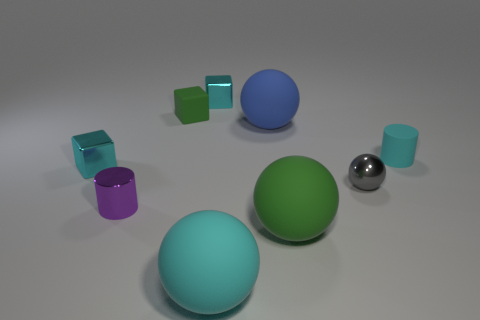Add 1 small gray metal balls. How many objects exist? 10 Subtract all cyan cubes. How many cubes are left? 1 Subtract all green cubes. How many cubes are left? 2 Subtract 2 balls. How many balls are left? 2 Add 7 tiny gray rubber spheres. How many tiny gray rubber spheres exist? 7 Subtract 0 yellow cylinders. How many objects are left? 9 Subtract all blocks. How many objects are left? 6 Subtract all purple balls. Subtract all yellow blocks. How many balls are left? 4 Subtract all blue cubes. How many green balls are left? 1 Subtract all green cubes. Subtract all brown rubber objects. How many objects are left? 8 